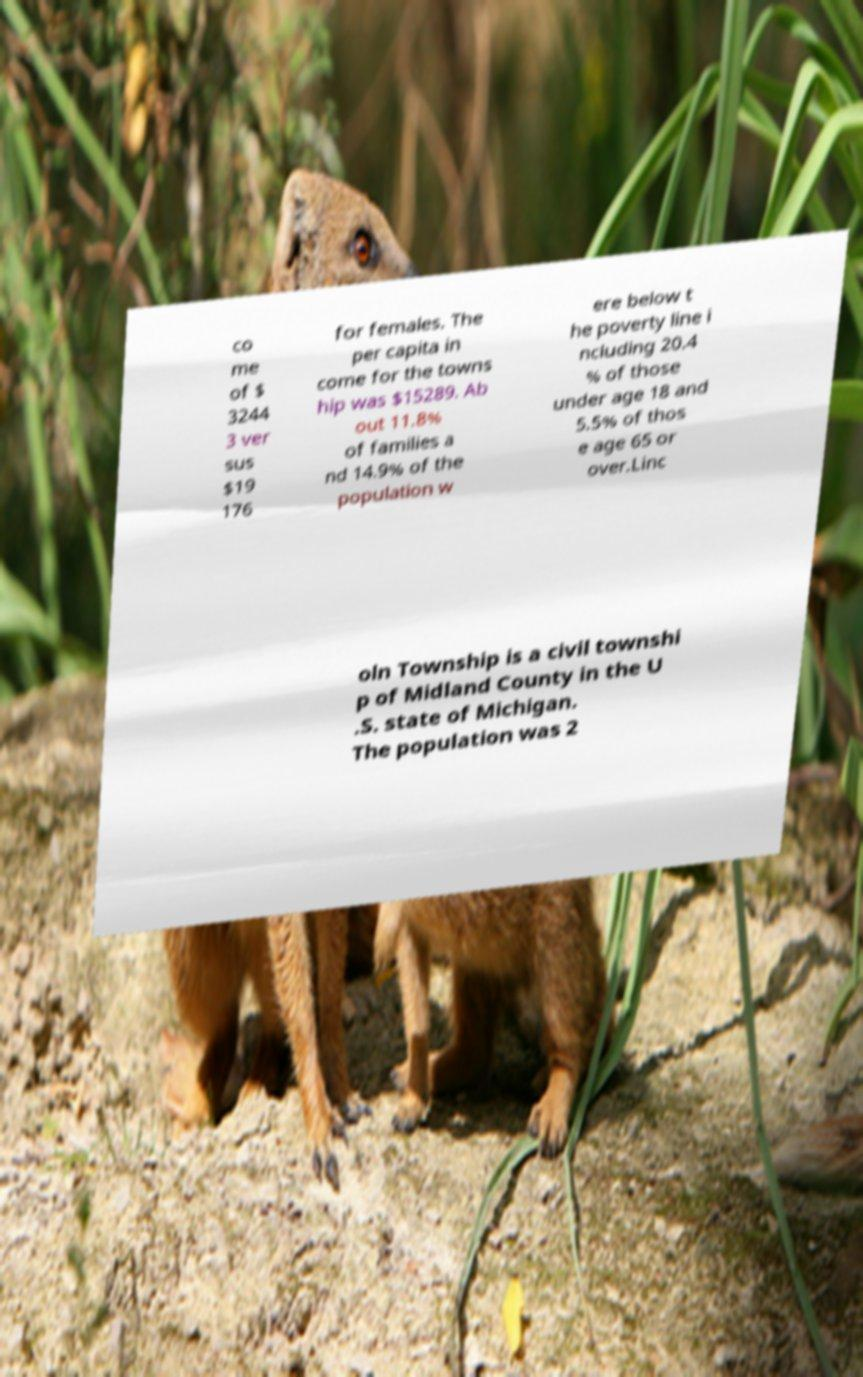Can you accurately transcribe the text from the provided image for me? co me of $ 3244 3 ver sus $19 176 for females. The per capita in come for the towns hip was $15289. Ab out 11.8% of families a nd 14.9% of the population w ere below t he poverty line i ncluding 20.4 % of those under age 18 and 5.5% of thos e age 65 or over.Linc oln Township is a civil townshi p of Midland County in the U .S. state of Michigan. The population was 2 